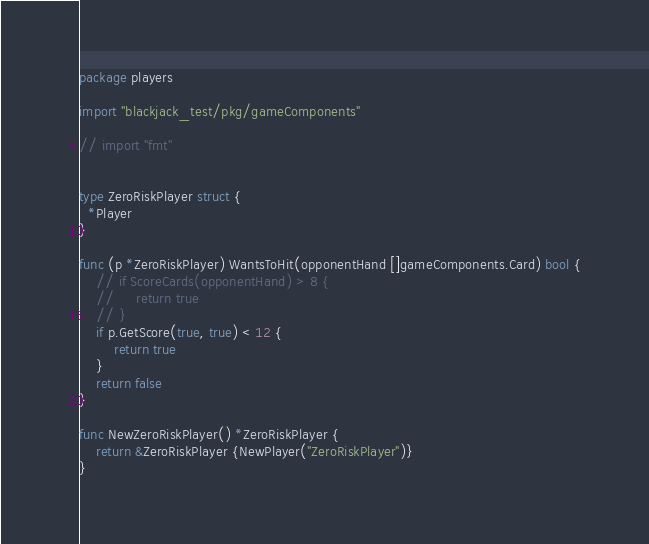Convert code to text. <code><loc_0><loc_0><loc_500><loc_500><_Go_>
package players

import "blackjack_test/pkg/gameComponents"

// import "fmt"


type ZeroRiskPlayer struct {
  *Player
}

func (p *ZeroRiskPlayer) WantsToHit(opponentHand []gameComponents.Card) bool {
    // if ScoreCards(opponentHand) > 8 {
    //     return true
    // }
    if p.GetScore(true, true) < 12 {
        return true
    }
    return false
}

func NewZeroRiskPlayer() *ZeroRiskPlayer {
    return &ZeroRiskPlayer {NewPlayer("ZeroRiskPlayer")}
}
</code> 